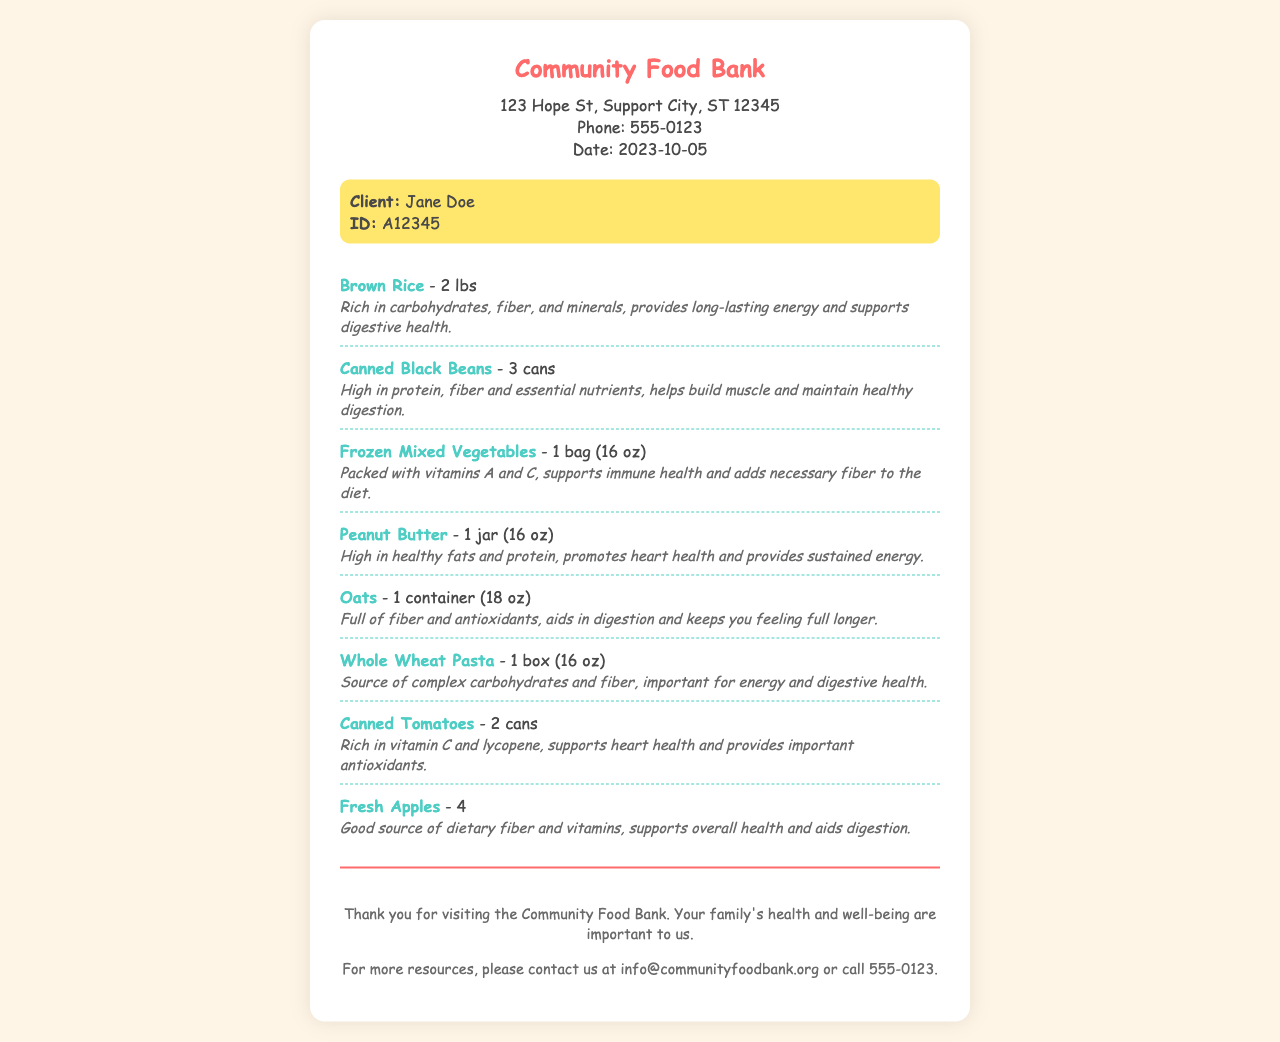What is the name of the organization? The organization name is stated at the top of the receipt.
Answer: Community Food Bank What is the date of the visit? The date is clearly labeled in the header section of the document.
Answer: 2023-10-05 How many cans of black beans were received? The amount of each item is specified in the list of received items.
Answer: 3 cans What is the weight of brown rice received? The weight of brown rice is clearly mentioned in the corresponding item description.
Answer: 2 lbs Which item provides high healthy fats and protein? This item is identified by its nutritional benefits in the receipt.
Answer: Peanut Butter What vitamins do frozen mixed vegetables help support? The nutritional benefits are listed for each item, highlighting key vitamins.
Answer: Vitamins A and C How many fresh apples did the client receive? The quantity of fresh apples is specified in the items list on the receipt.
Answer: 4 What is the nutritional role of oatmeal mentioned in the document? This information can be found in the description of the oats under nutritional benefits.
Answer: Aids in digestion What type of pasta was provided? The item type is specified under the list of items received.
Answer: Whole Wheat Pasta 